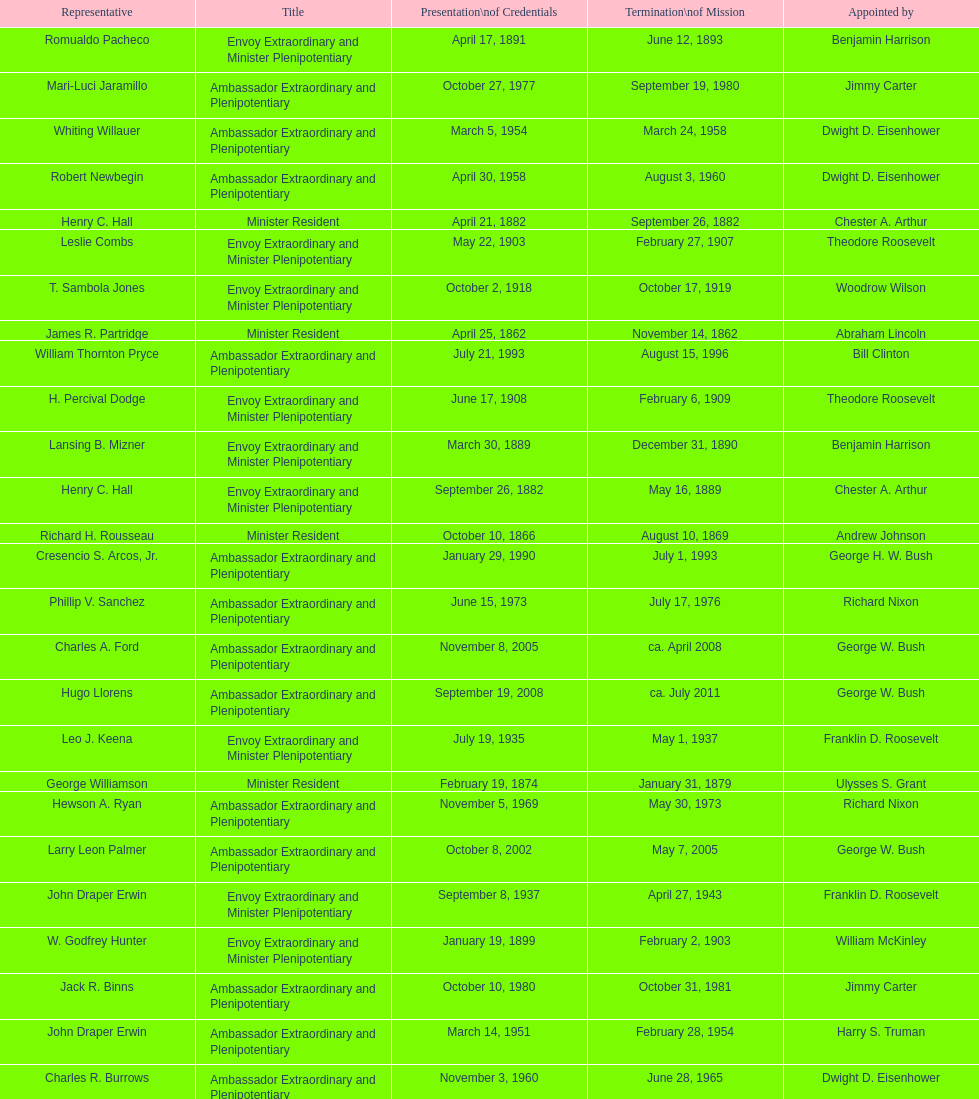Which date is below april 17, 1854 March 17, 1860. 